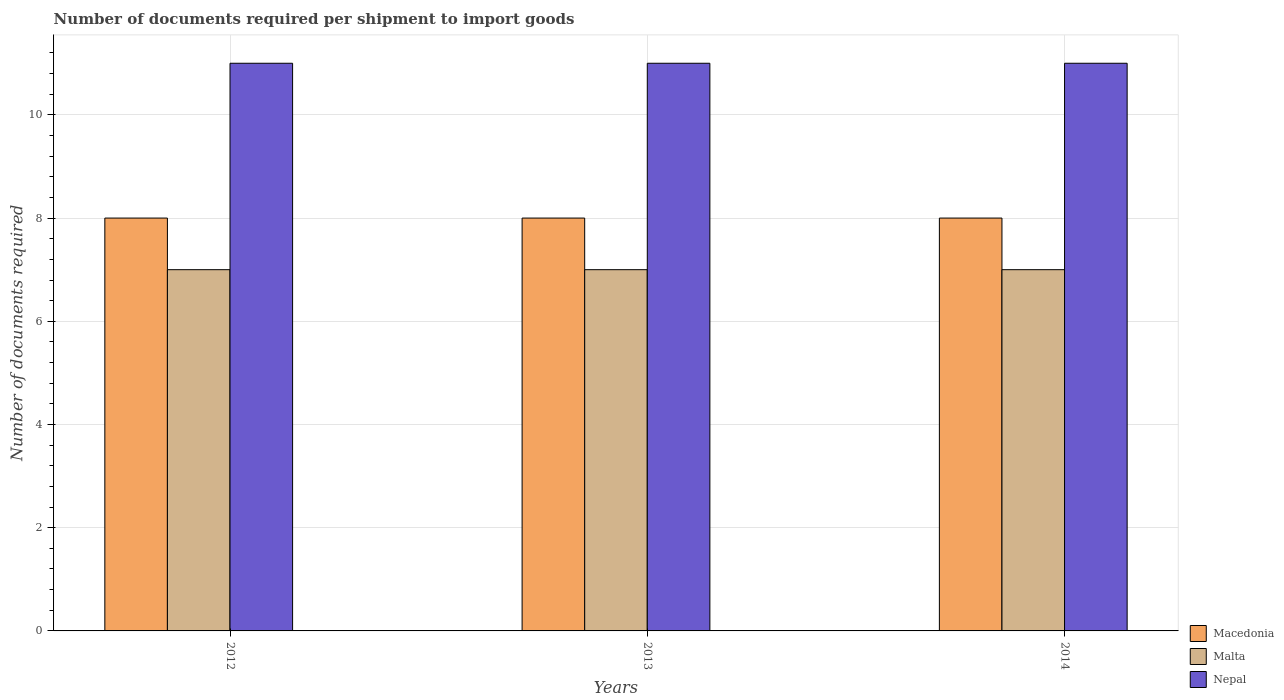How many different coloured bars are there?
Offer a terse response. 3. How many groups of bars are there?
Your response must be concise. 3. Are the number of bars on each tick of the X-axis equal?
Give a very brief answer. Yes. How many bars are there on the 1st tick from the left?
Provide a succinct answer. 3. How many bars are there on the 2nd tick from the right?
Provide a succinct answer. 3. What is the label of the 1st group of bars from the left?
Offer a terse response. 2012. What is the number of documents required per shipment to import goods in Nepal in 2012?
Your answer should be very brief. 11. Across all years, what is the maximum number of documents required per shipment to import goods in Malta?
Provide a short and direct response. 7. Across all years, what is the minimum number of documents required per shipment to import goods in Macedonia?
Offer a very short reply. 8. What is the total number of documents required per shipment to import goods in Macedonia in the graph?
Your response must be concise. 24. What is the difference between the number of documents required per shipment to import goods in Malta in 2013 and that in 2014?
Your answer should be compact. 0. What is the difference between the number of documents required per shipment to import goods in Nepal in 2014 and the number of documents required per shipment to import goods in Malta in 2012?
Offer a terse response. 4. What is the average number of documents required per shipment to import goods in Macedonia per year?
Your answer should be very brief. 8. In the year 2014, what is the difference between the number of documents required per shipment to import goods in Macedonia and number of documents required per shipment to import goods in Malta?
Ensure brevity in your answer.  1. In how many years, is the number of documents required per shipment to import goods in Nepal greater than 8.4?
Your answer should be compact. 3. Is the difference between the number of documents required per shipment to import goods in Macedonia in 2013 and 2014 greater than the difference between the number of documents required per shipment to import goods in Malta in 2013 and 2014?
Your answer should be compact. No. What is the difference between the highest and the lowest number of documents required per shipment to import goods in Nepal?
Ensure brevity in your answer.  0. Is the sum of the number of documents required per shipment to import goods in Malta in 2013 and 2014 greater than the maximum number of documents required per shipment to import goods in Nepal across all years?
Ensure brevity in your answer.  Yes. What does the 3rd bar from the left in 2014 represents?
Ensure brevity in your answer.  Nepal. What does the 2nd bar from the right in 2013 represents?
Ensure brevity in your answer.  Malta. Is it the case that in every year, the sum of the number of documents required per shipment to import goods in Malta and number of documents required per shipment to import goods in Nepal is greater than the number of documents required per shipment to import goods in Macedonia?
Your response must be concise. Yes. How many bars are there?
Offer a very short reply. 9. Are all the bars in the graph horizontal?
Your answer should be very brief. No. Are the values on the major ticks of Y-axis written in scientific E-notation?
Offer a terse response. No. How many legend labels are there?
Provide a short and direct response. 3. What is the title of the graph?
Offer a very short reply. Number of documents required per shipment to import goods. What is the label or title of the Y-axis?
Provide a short and direct response. Number of documents required. What is the Number of documents required of Macedonia in 2012?
Make the answer very short. 8. What is the Number of documents required of Macedonia in 2013?
Make the answer very short. 8. What is the Number of documents required in Malta in 2013?
Keep it short and to the point. 7. What is the Number of documents required in Nepal in 2013?
Provide a succinct answer. 11. What is the Number of documents required in Macedonia in 2014?
Provide a short and direct response. 8. What is the Number of documents required in Nepal in 2014?
Your answer should be very brief. 11. Across all years, what is the maximum Number of documents required of Macedonia?
Offer a very short reply. 8. Across all years, what is the maximum Number of documents required of Malta?
Give a very brief answer. 7. Across all years, what is the minimum Number of documents required of Nepal?
Offer a very short reply. 11. What is the total Number of documents required of Macedonia in the graph?
Make the answer very short. 24. What is the difference between the Number of documents required in Nepal in 2012 and that in 2013?
Your response must be concise. 0. What is the difference between the Number of documents required in Macedonia in 2012 and that in 2014?
Make the answer very short. 0. What is the difference between the Number of documents required of Malta in 2012 and that in 2014?
Offer a very short reply. 0. What is the difference between the Number of documents required of Macedonia in 2013 and that in 2014?
Offer a very short reply. 0. What is the difference between the Number of documents required in Malta in 2013 and that in 2014?
Make the answer very short. 0. What is the difference between the Number of documents required of Nepal in 2013 and that in 2014?
Offer a terse response. 0. What is the difference between the Number of documents required of Malta in 2012 and the Number of documents required of Nepal in 2013?
Ensure brevity in your answer.  -4. What is the difference between the Number of documents required in Macedonia in 2012 and the Number of documents required in Malta in 2014?
Your answer should be very brief. 1. What is the difference between the Number of documents required of Malta in 2012 and the Number of documents required of Nepal in 2014?
Your answer should be very brief. -4. What is the difference between the Number of documents required in Macedonia in 2013 and the Number of documents required in Nepal in 2014?
Make the answer very short. -3. What is the average Number of documents required of Malta per year?
Provide a succinct answer. 7. What is the average Number of documents required of Nepal per year?
Keep it short and to the point. 11. In the year 2012, what is the difference between the Number of documents required in Macedonia and Number of documents required in Malta?
Your answer should be very brief. 1. In the year 2012, what is the difference between the Number of documents required of Macedonia and Number of documents required of Nepal?
Offer a terse response. -3. What is the ratio of the Number of documents required in Macedonia in 2012 to that in 2013?
Your answer should be compact. 1. What is the ratio of the Number of documents required of Malta in 2012 to that in 2013?
Ensure brevity in your answer.  1. What is the ratio of the Number of documents required of Nepal in 2012 to that in 2013?
Keep it short and to the point. 1. What is the ratio of the Number of documents required in Nepal in 2012 to that in 2014?
Provide a short and direct response. 1. What is the ratio of the Number of documents required of Malta in 2013 to that in 2014?
Provide a succinct answer. 1. What is the ratio of the Number of documents required of Nepal in 2013 to that in 2014?
Your response must be concise. 1. What is the difference between the highest and the second highest Number of documents required in Macedonia?
Your answer should be compact. 0. What is the difference between the highest and the second highest Number of documents required of Malta?
Provide a short and direct response. 0. What is the difference between the highest and the second highest Number of documents required of Nepal?
Give a very brief answer. 0. What is the difference between the highest and the lowest Number of documents required of Malta?
Your response must be concise. 0. What is the difference between the highest and the lowest Number of documents required in Nepal?
Your answer should be compact. 0. 